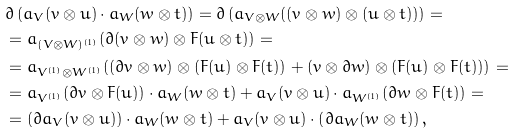<formula> <loc_0><loc_0><loc_500><loc_500>& \partial \left ( a _ { V } ( v \otimes u ) \cdot a _ { W } ( w \otimes t ) \right ) = \partial \left ( a _ { V \otimes W } ( ( v \otimes w ) \otimes ( u \otimes t ) ) \right ) = \\ & = a _ { ( V \otimes W ) ^ { ( 1 ) } } ( \partial ( v \otimes w ) \otimes F ( u \otimes t ) ) = \\ & = a _ { V ^ { ( 1 ) } \otimes W ^ { ( 1 ) } } ( ( \partial v \otimes w ) \otimes ( F ( u ) \otimes F ( t ) ) + ( v \otimes \partial w ) \otimes ( F ( u ) \otimes F ( t ) ) ) = \\ & = a _ { V ^ { ( 1 ) } } ( \partial v \otimes F ( u ) ) \cdot a _ { W } ( w \otimes t ) + a _ { V } ( v \otimes u ) \cdot a _ { W ^ { ( 1 ) } } ( \partial w \otimes F ( t ) ) = \\ & = \left ( \partial a _ { V } ( v \otimes u ) \right ) \cdot a _ { W } ( w \otimes t ) + a _ { V } ( v \otimes u ) \cdot \left ( \partial a _ { W } ( w \otimes t ) \right ) ,</formula> 